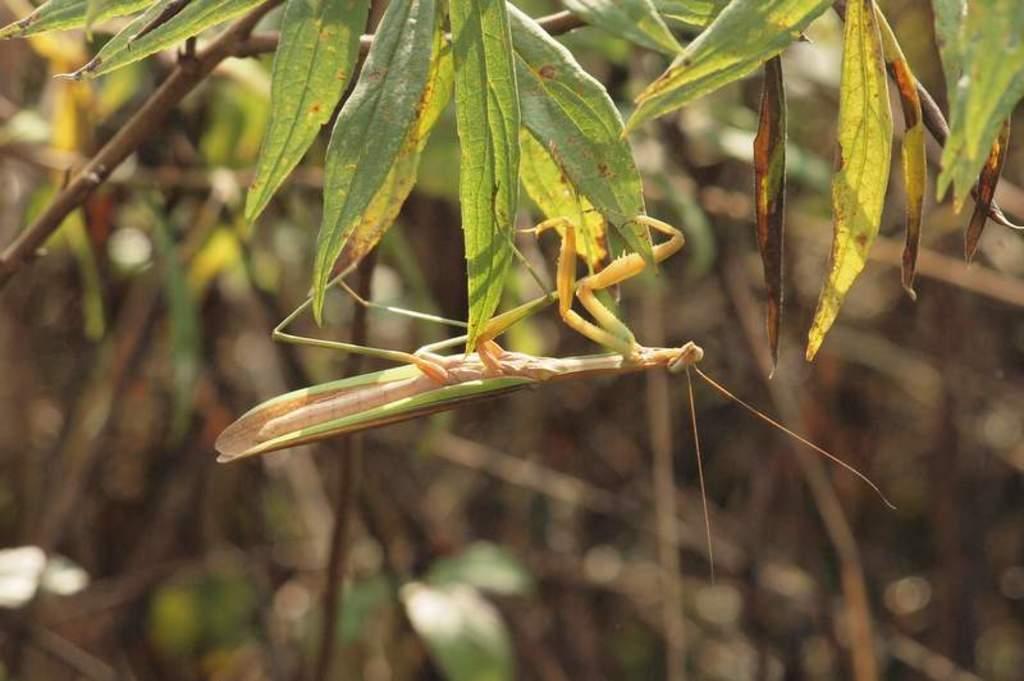In one or two sentences, can you explain what this image depicts? In this image I see a grasshopper and I see the green leaves and I see that it is blurred in the background. 